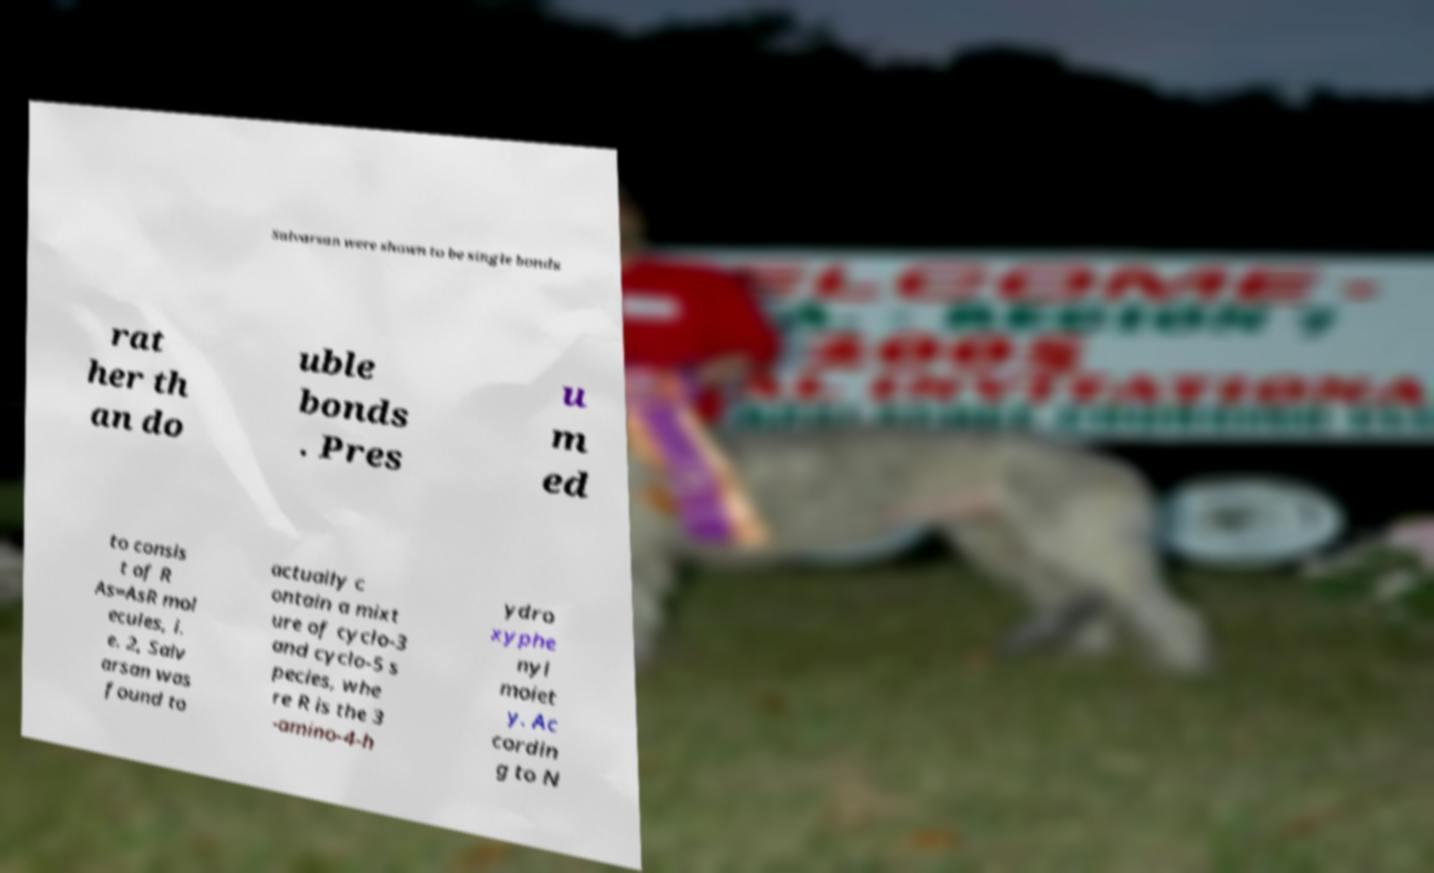What messages or text are displayed in this image? I need them in a readable, typed format. Salvarsan were shown to be single bonds rat her th an do uble bonds . Pres u m ed to consis t of R As=AsR mol ecules, i. e. 2, Salv arsan was found to actually c ontain a mixt ure of cyclo-3 and cyclo-5 s pecies, whe re R is the 3 -amino-4-h ydro xyphe nyl moiet y. Ac cordin g to N 